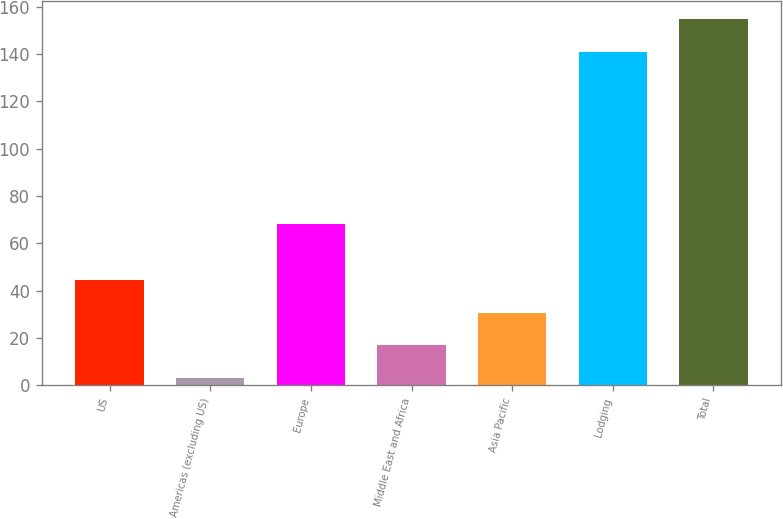<chart> <loc_0><loc_0><loc_500><loc_500><bar_chart><fcel>US<fcel>Americas (excluding US)<fcel>Europe<fcel>Middle East and Africa<fcel>Asia Pacific<fcel>Lodging<fcel>Total<nl><fcel>44.4<fcel>3<fcel>68<fcel>16.8<fcel>30.6<fcel>141<fcel>154.8<nl></chart> 